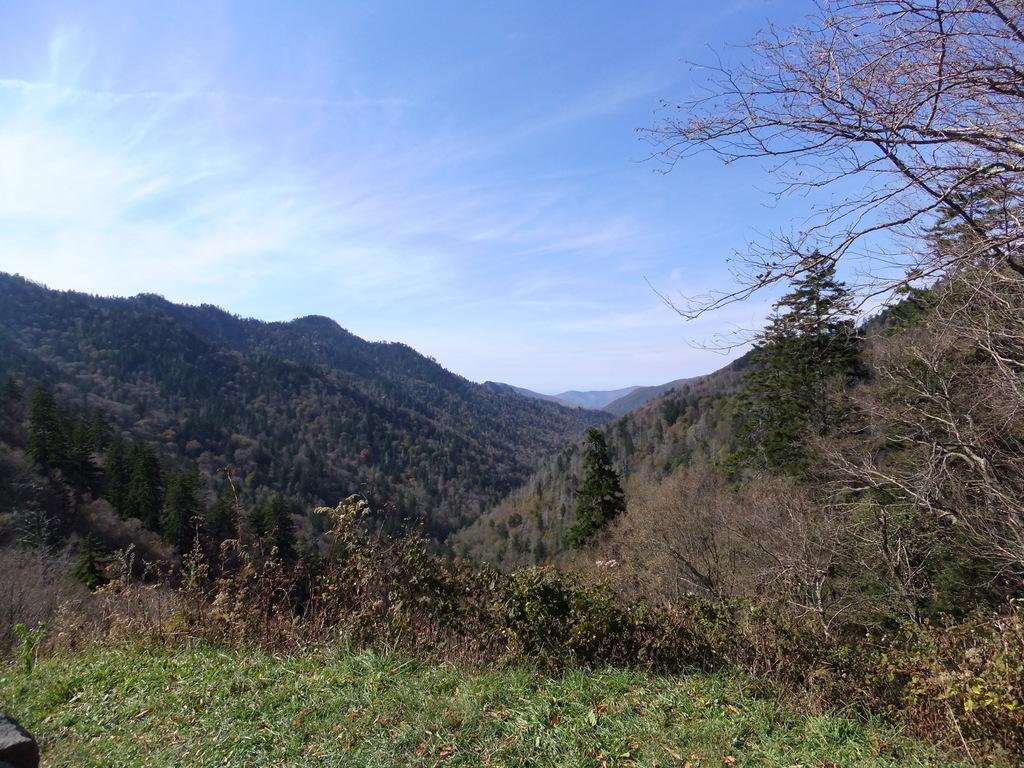In one or two sentences, can you explain what this image depicts? In this picture we can see mountains and in front of the mountains we have grass, trees and above the mountain there is sky with clouds. 